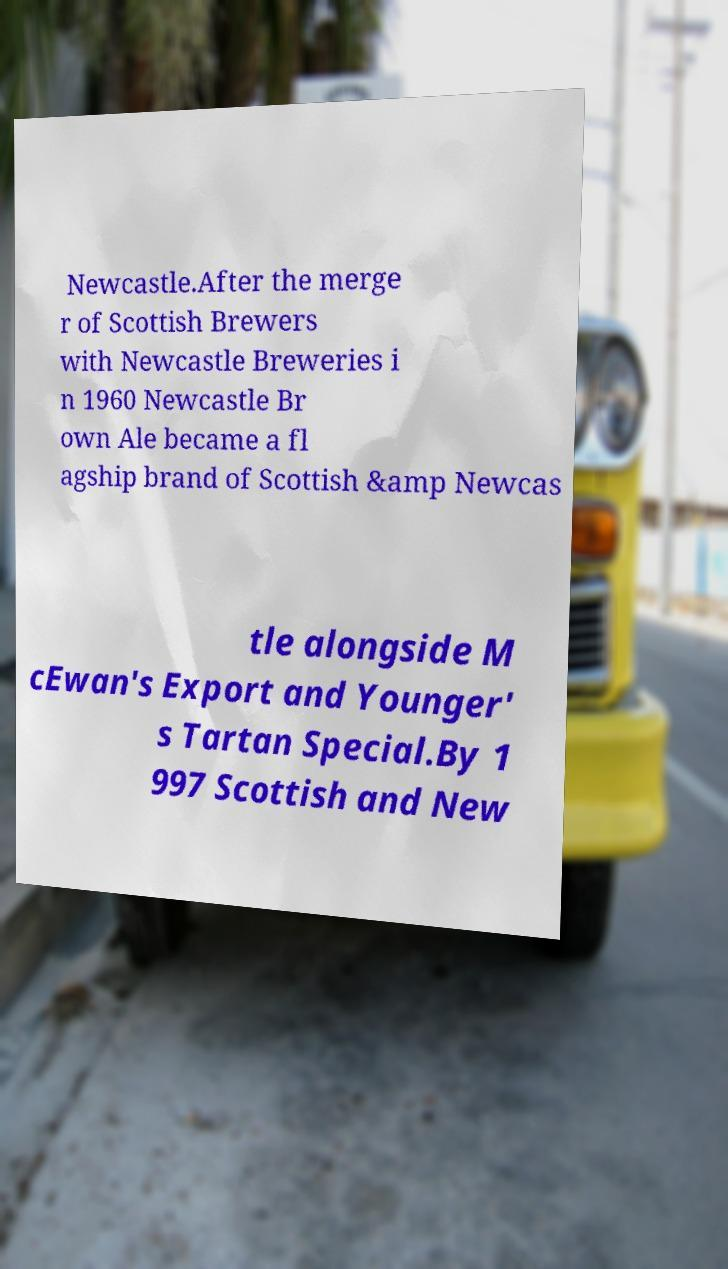Please identify and transcribe the text found in this image. Newcastle.After the merge r of Scottish Brewers with Newcastle Breweries i n 1960 Newcastle Br own Ale became a fl agship brand of Scottish &amp Newcas tle alongside M cEwan's Export and Younger' s Tartan Special.By 1 997 Scottish and New 